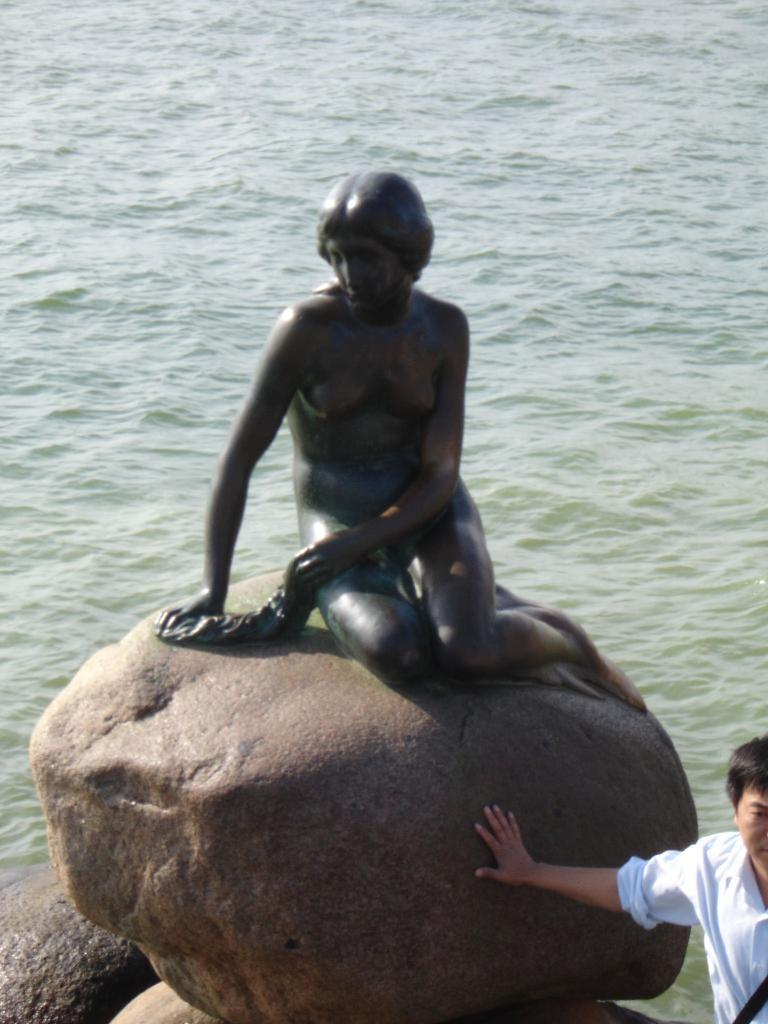What is the main subject on the rock in the image? There is a sculpture on a rock in the image. Can you describe the person in the image? There is a person in the image. What can be seen in the background of the image? There is water visible in the background of the image. What type of teeth can be seen in the sculpture in the image? There are no teeth visible in the sculpture in the image. How does the water in the background increase in the image? The water in the background does not increase in the image; it remains at a constant level. 